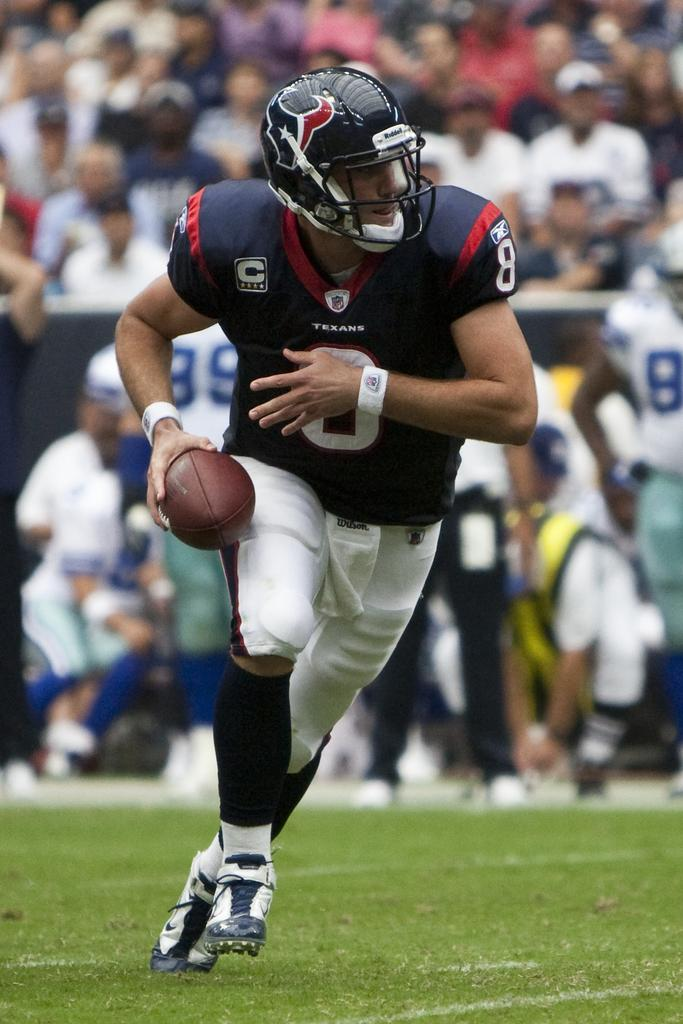Where is the image taken from? The image is taken on the ground. What is the main subject in the image? There is a man in the middle of the image. What is the man holding in the image? The man is holding a brown-colored ball. What can be seen in the background of the image? In the background, there are people sitting and watching a match. Where is the shelf located in the image? There is no shelf present in the image. What type of self-care activity is the man engaged in during the match? The image does not show the man engaging in any self-care activity; he is holding a brown-colored ball. 